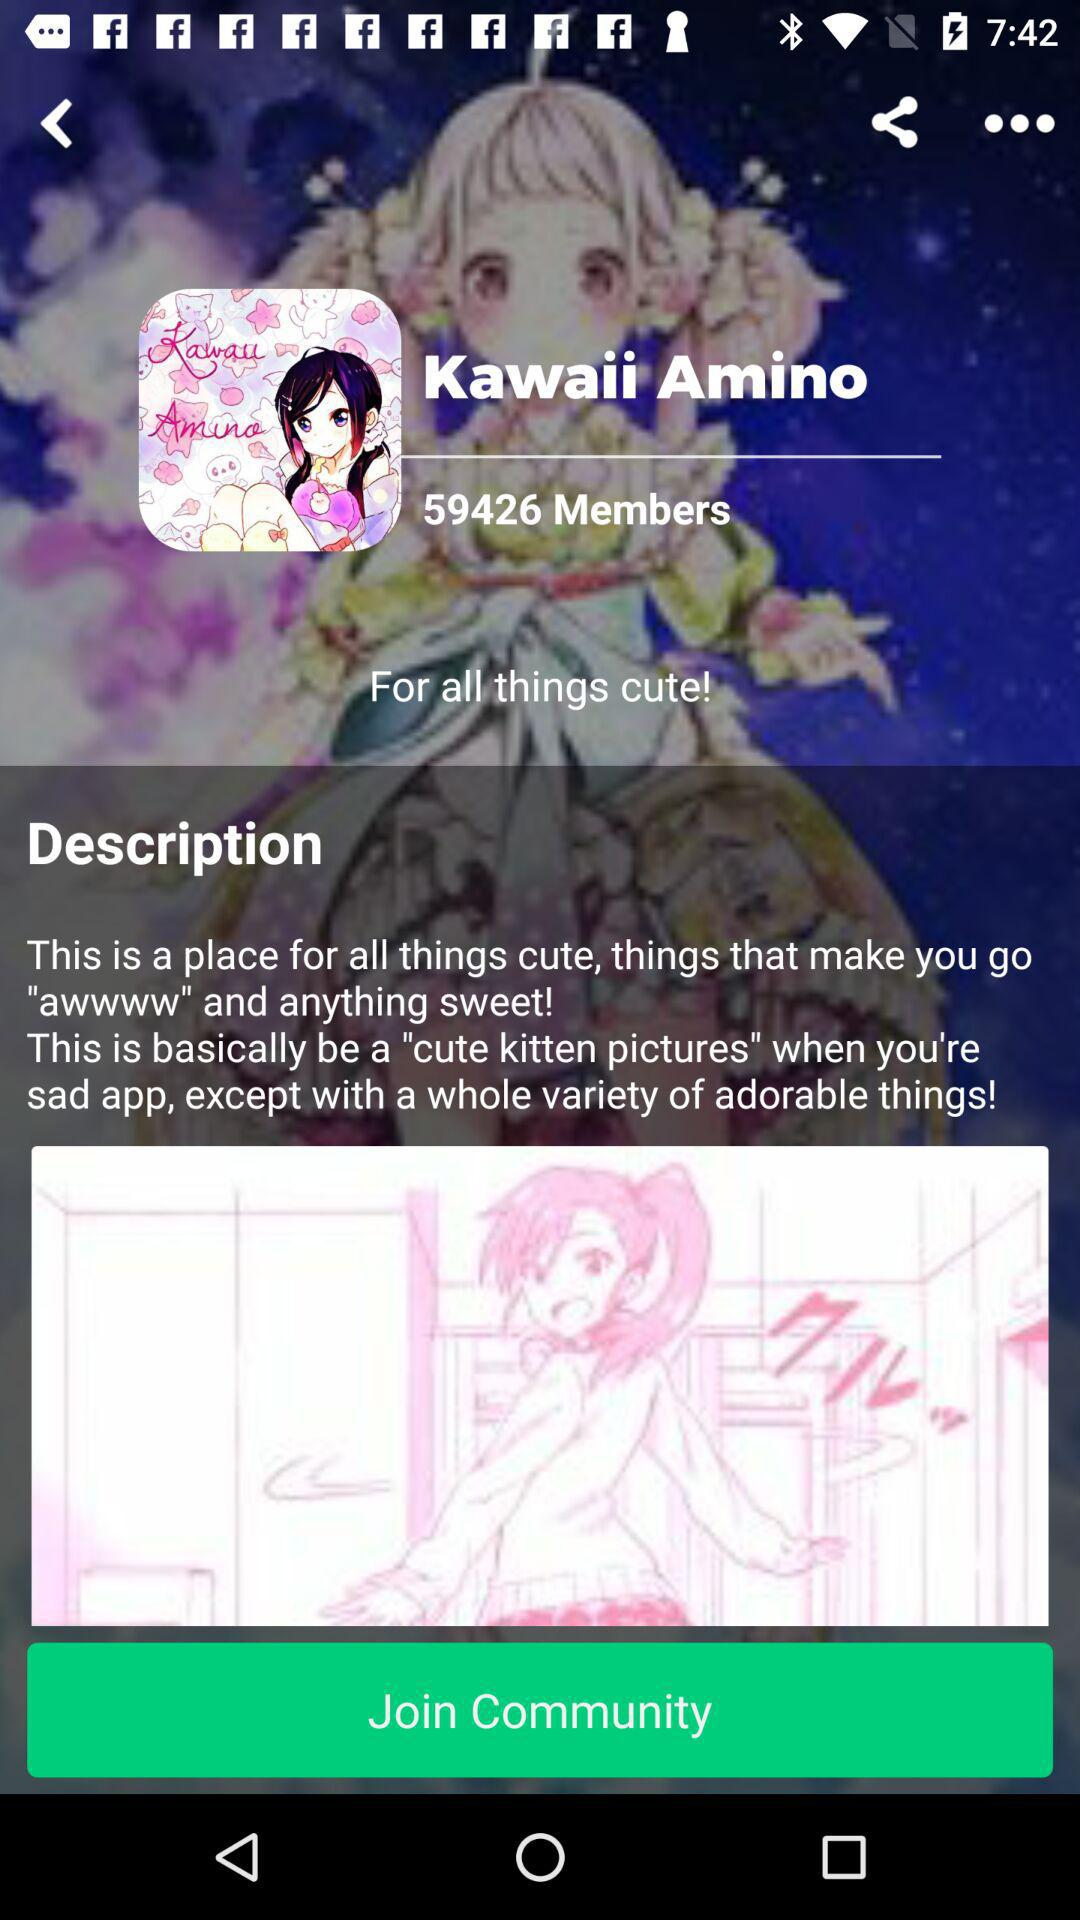What is it basically included in this?
When the provided information is insufficient, respond with <no answer>. <no answer> 